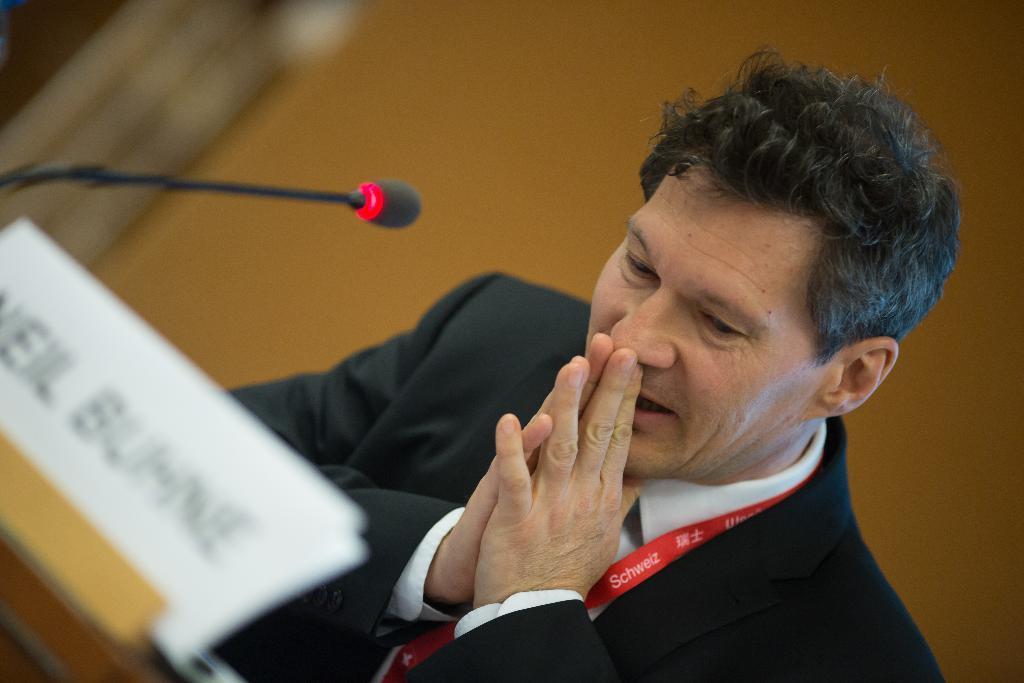Describe this image in one or two sentences. There is a person in black color suit sitting on a chair in front of a table. On which, there is a name board and a mic. In the background, there is a yellow color wall. 